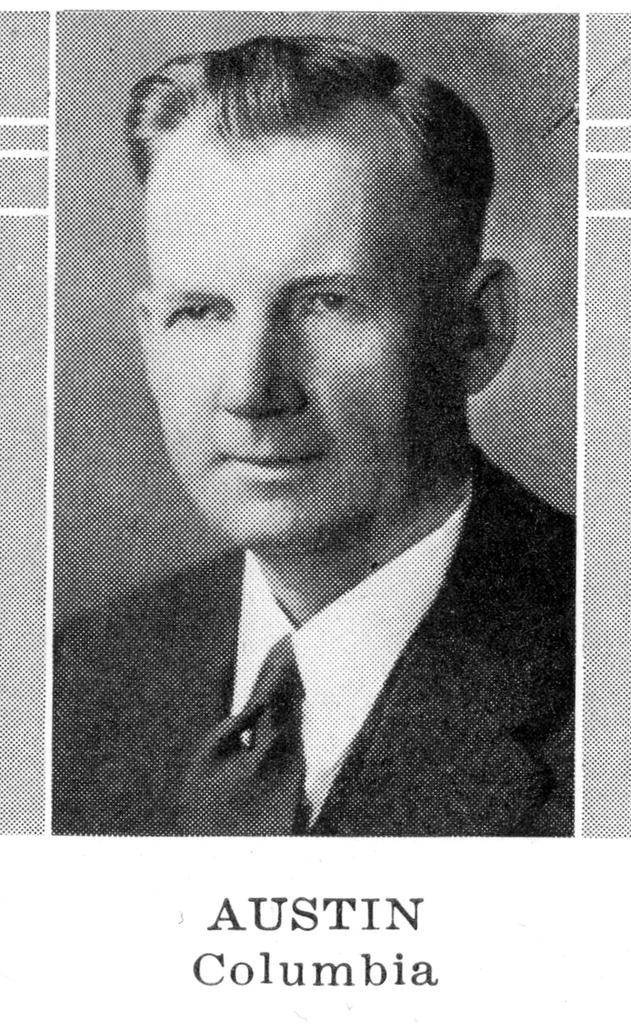What is the main subject of the image? There is a photograph of a man in the image. What is the man wearing in the image? The man is wearing a suit in the image. Is there any text present in the image? Yes, there is text at the bottom of the image. What is the color scheme of the image? The image is black and white. What type of degree is the man holding in the image? There is no degree visible in the image; it only shows a photograph of a man wearing a suit. What appliance is the man using in the image? There is no appliance present in the image; it only shows a photograph of a man wearing a suit. 